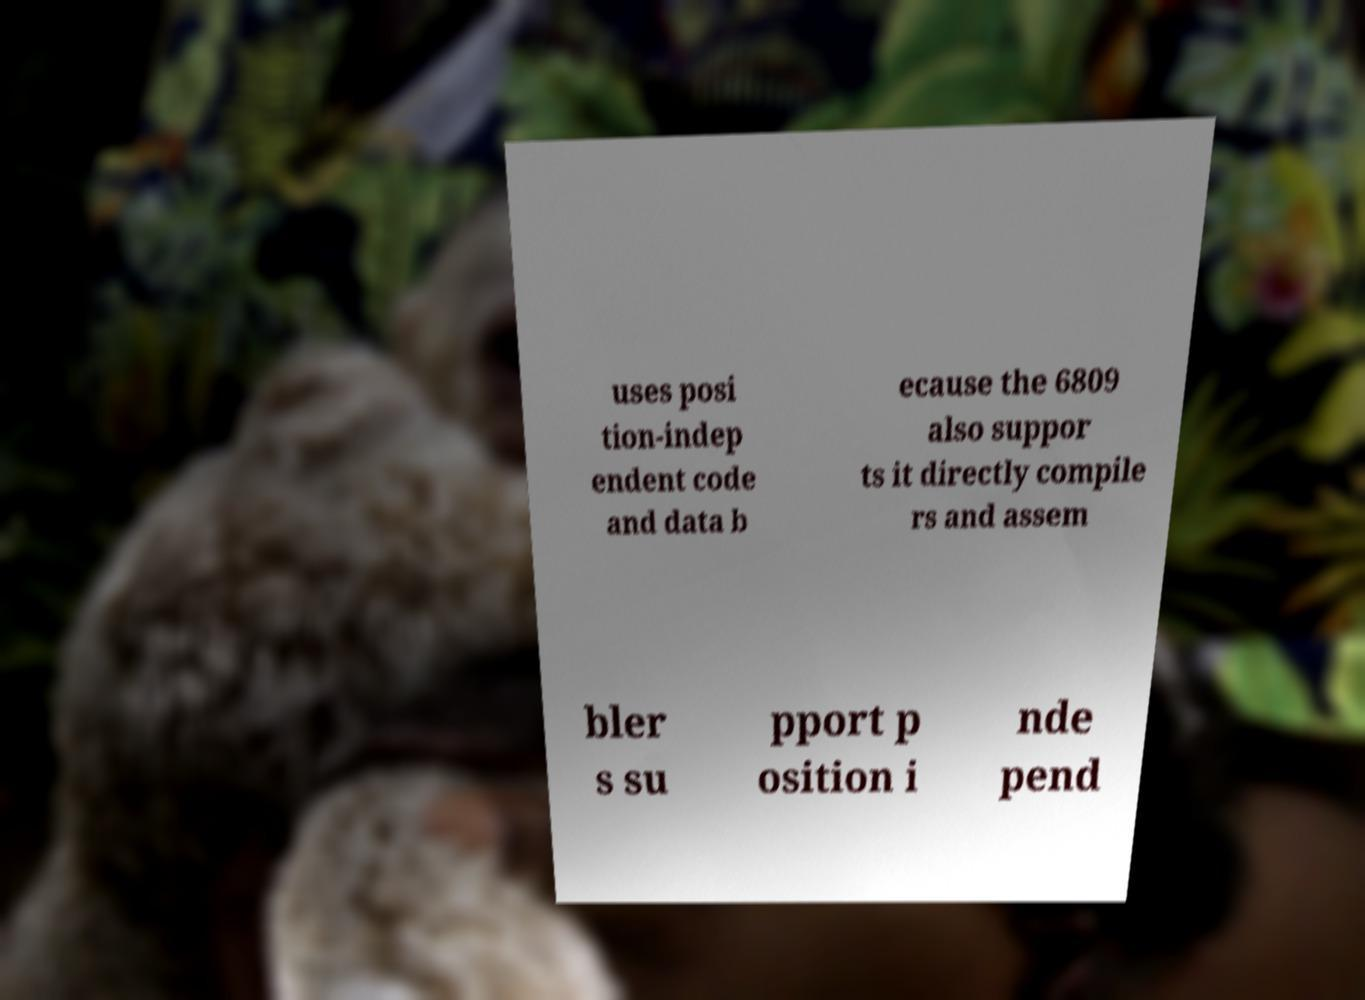For documentation purposes, I need the text within this image transcribed. Could you provide that? uses posi tion-indep endent code and data b ecause the 6809 also suppor ts it directly compile rs and assem bler s su pport p osition i nde pend 